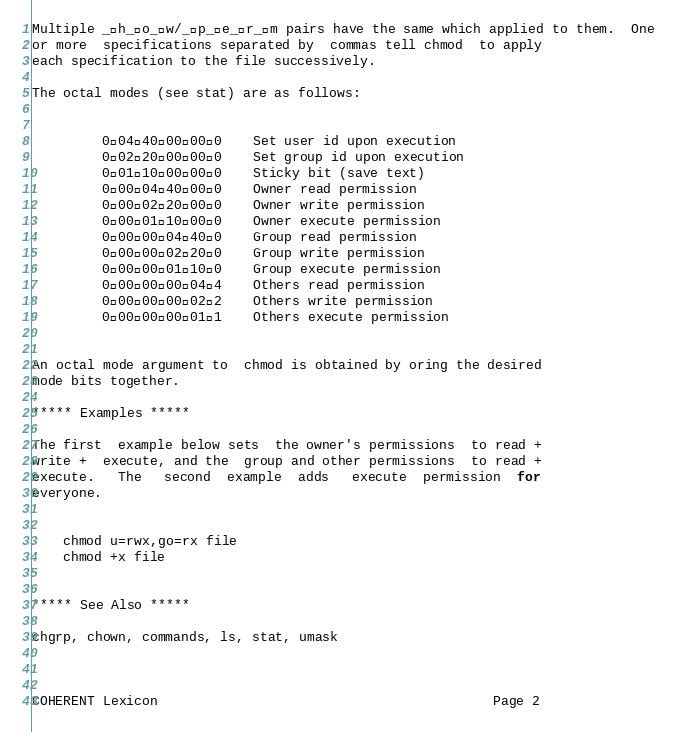<code> <loc_0><loc_0><loc_500><loc_500><_C_>
Multiple _h_o_w/_p_e_r_m pairs have the same which applied to them.  One
or more  specifications separated by  commas tell chmod  to apply
each specification to the file successively.

The octal modes (see stat) are as follows:


         0044000000    Set user id upon execution
         0022000000    Set group id upon execution
         0011000000    Sticky bit (save text)
         0000440000    Owner read permission
         0000220000    Owner write permission
         0000110000    Owner execute permission
         0000004400    Group read permission
         0000002200    Group write permission
         0000001100    Group execute permission
         0000000044    Others read permission
         0000000022    Others write permission
         0000000011    Others execute permission


An octal mode argument to  chmod is obtained by oring the desired
mode bits together.

***** Examples *****

The first  example below sets  the owner's permissions  to read +
write +  execute, and the  group and other permissions  to read +
execute.   The   second  example  adds   execute  permission  for
everyone.


    chmod u=rwx,go=rx file
    chmod +x file


***** See Also *****

chgrp, chown, commands, ls, stat, umask



COHERENT Lexicon                                           Page 2


</code> 